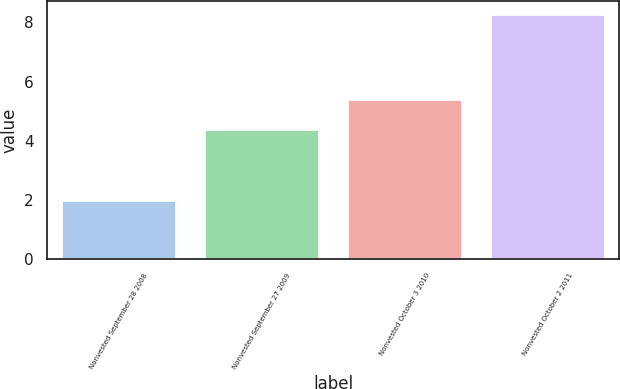Convert chart. <chart><loc_0><loc_0><loc_500><loc_500><bar_chart><fcel>Nonvested September 28 2008<fcel>Nonvested September 27 2009<fcel>Nonvested October 3 2010<fcel>Nonvested October 2 2011<nl><fcel>2<fcel>4.4<fcel>5.4<fcel>8.3<nl></chart> 